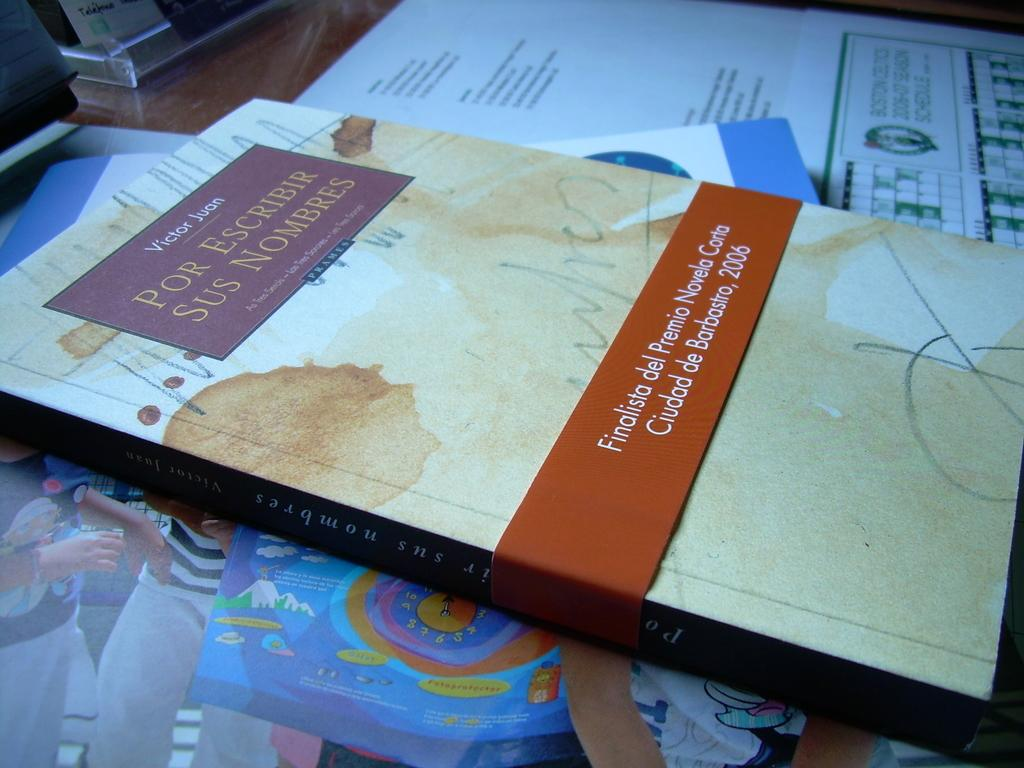Provide a one-sentence caption for the provided image. a book that says 'por escribir sus nombres' on the top of it. 